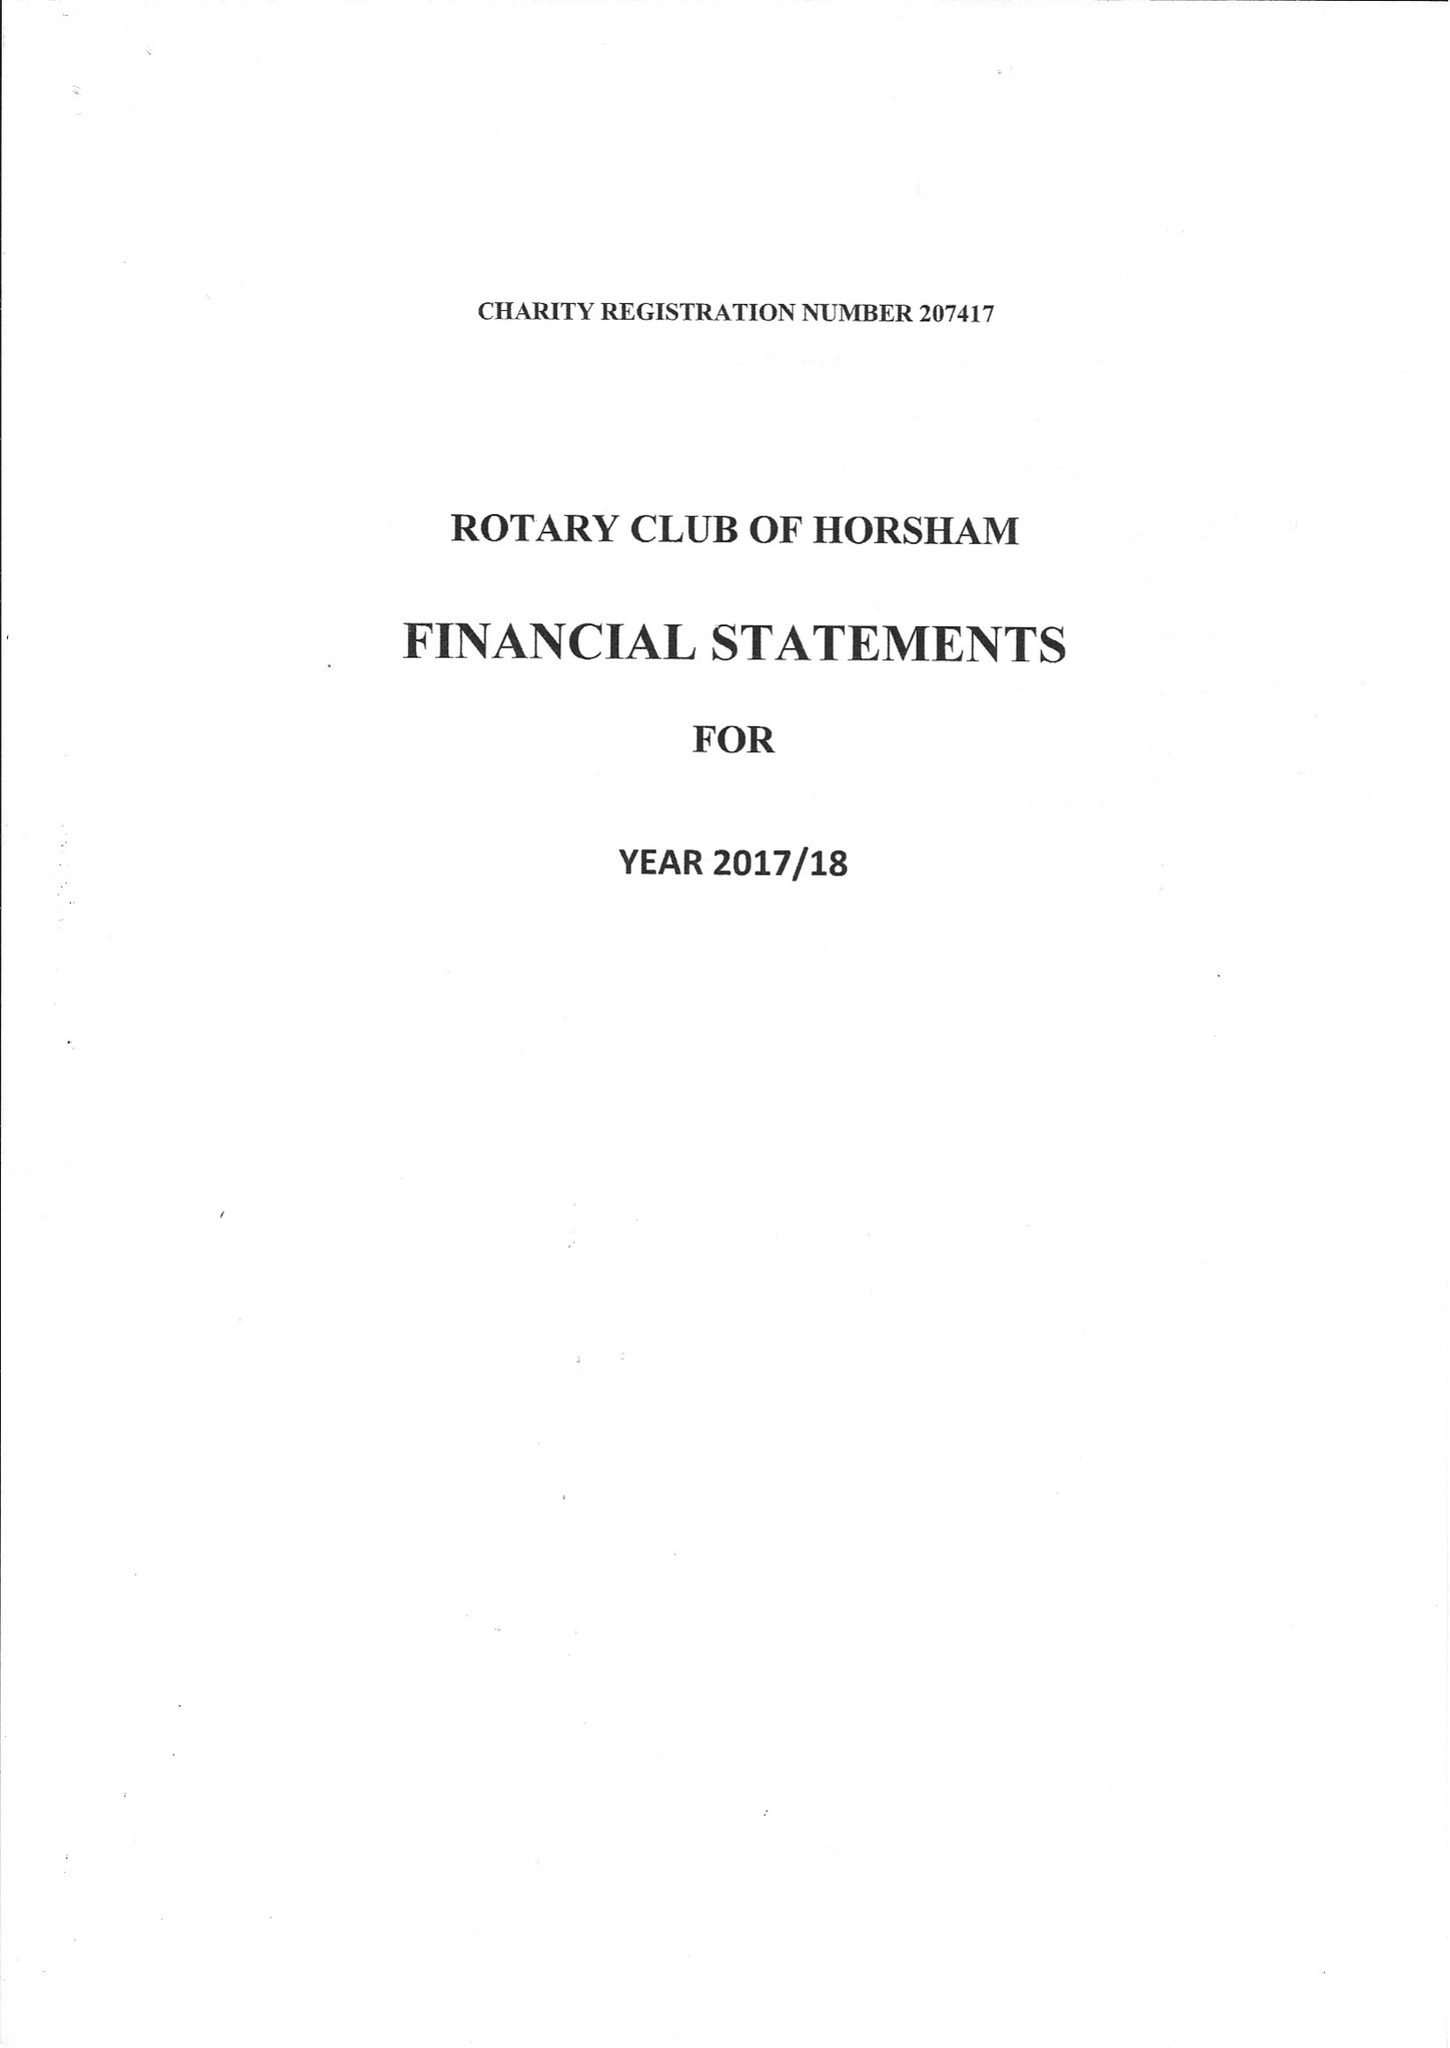What is the value for the spending_annually_in_british_pounds?
Answer the question using a single word or phrase. 33808.00 